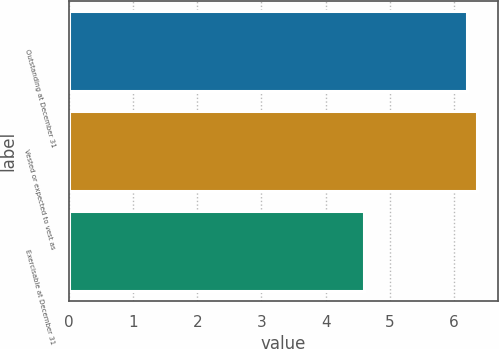Convert chart. <chart><loc_0><loc_0><loc_500><loc_500><bar_chart><fcel>Outstanding at December 31<fcel>Vested or expected to vest as<fcel>Exercisable at December 31<nl><fcel>6.2<fcel>6.36<fcel>4.6<nl></chart> 